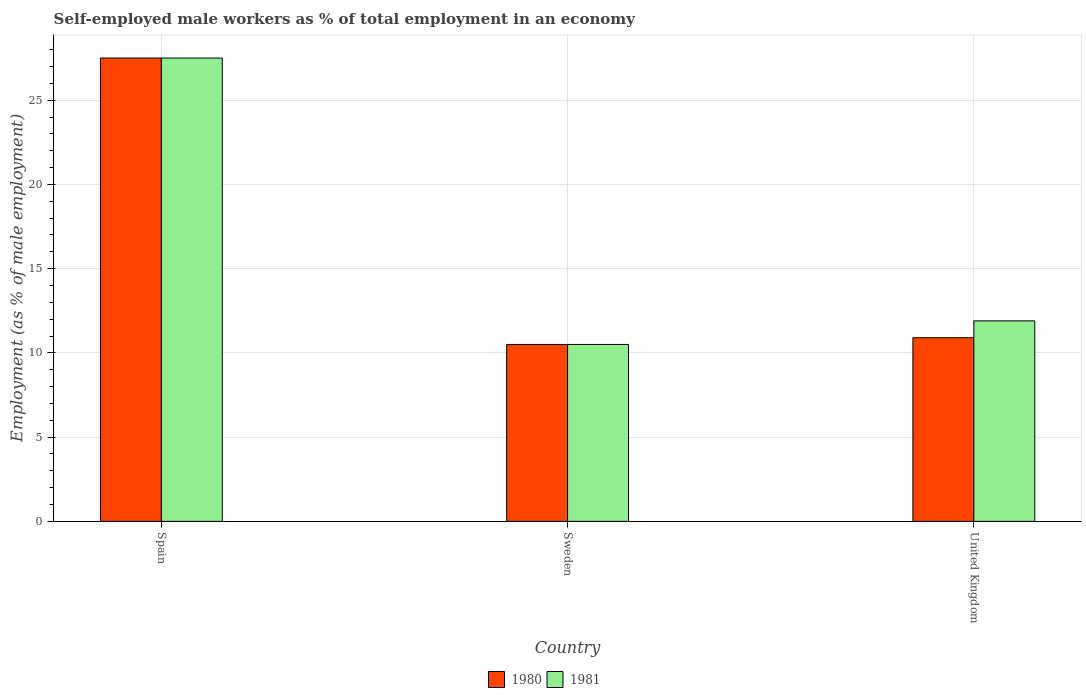How many bars are there on the 1st tick from the right?
Provide a succinct answer. 2. What is the label of the 1st group of bars from the left?
Offer a very short reply. Spain. In how many cases, is the number of bars for a given country not equal to the number of legend labels?
Your answer should be compact. 0. What is the percentage of self-employed male workers in 1980 in Spain?
Offer a terse response. 27.5. Across all countries, what is the minimum percentage of self-employed male workers in 1981?
Your answer should be very brief. 10.5. What is the total percentage of self-employed male workers in 1980 in the graph?
Your answer should be very brief. 48.9. What is the difference between the percentage of self-employed male workers in 1981 in Sweden and that in United Kingdom?
Your answer should be very brief. -1.4. What is the difference between the percentage of self-employed male workers in 1981 in Sweden and the percentage of self-employed male workers in 1980 in United Kingdom?
Ensure brevity in your answer.  -0.4. What is the average percentage of self-employed male workers in 1980 per country?
Keep it short and to the point. 16.3. In how many countries, is the percentage of self-employed male workers in 1981 greater than 8 %?
Offer a terse response. 3. What is the ratio of the percentage of self-employed male workers in 1980 in Spain to that in Sweden?
Ensure brevity in your answer.  2.62. Is the difference between the percentage of self-employed male workers in 1980 in Sweden and United Kingdom greater than the difference between the percentage of self-employed male workers in 1981 in Sweden and United Kingdom?
Make the answer very short. Yes. What is the difference between the highest and the second highest percentage of self-employed male workers in 1981?
Ensure brevity in your answer.  1.4. What does the 2nd bar from the left in Sweden represents?
Ensure brevity in your answer.  1981. What does the 1st bar from the right in Sweden represents?
Provide a short and direct response. 1981. How many bars are there?
Your answer should be compact. 6. How many countries are there in the graph?
Provide a short and direct response. 3. Are the values on the major ticks of Y-axis written in scientific E-notation?
Your answer should be very brief. No. Where does the legend appear in the graph?
Your response must be concise. Bottom center. How many legend labels are there?
Your answer should be very brief. 2. What is the title of the graph?
Provide a succinct answer. Self-employed male workers as % of total employment in an economy. Does "1976" appear as one of the legend labels in the graph?
Offer a very short reply. No. What is the label or title of the Y-axis?
Provide a short and direct response. Employment (as % of male employment). What is the Employment (as % of male employment) in 1980 in Sweden?
Make the answer very short. 10.5. What is the Employment (as % of male employment) of 1981 in Sweden?
Make the answer very short. 10.5. What is the Employment (as % of male employment) of 1980 in United Kingdom?
Give a very brief answer. 10.9. What is the Employment (as % of male employment) of 1981 in United Kingdom?
Your answer should be compact. 11.9. Across all countries, what is the maximum Employment (as % of male employment) in 1980?
Offer a terse response. 27.5. What is the total Employment (as % of male employment) in 1980 in the graph?
Your answer should be compact. 48.9. What is the total Employment (as % of male employment) in 1981 in the graph?
Ensure brevity in your answer.  49.9. What is the difference between the Employment (as % of male employment) of 1981 in Spain and that in Sweden?
Offer a very short reply. 17. What is the difference between the Employment (as % of male employment) of 1980 in Spain and that in United Kingdom?
Give a very brief answer. 16.6. What is the difference between the Employment (as % of male employment) of 1981 in Spain and that in United Kingdom?
Your response must be concise. 15.6. What is the difference between the Employment (as % of male employment) of 1981 in Sweden and that in United Kingdom?
Keep it short and to the point. -1.4. What is the difference between the Employment (as % of male employment) of 1980 in Spain and the Employment (as % of male employment) of 1981 in United Kingdom?
Provide a short and direct response. 15.6. What is the average Employment (as % of male employment) in 1981 per country?
Your response must be concise. 16.63. What is the ratio of the Employment (as % of male employment) of 1980 in Spain to that in Sweden?
Keep it short and to the point. 2.62. What is the ratio of the Employment (as % of male employment) of 1981 in Spain to that in Sweden?
Offer a terse response. 2.62. What is the ratio of the Employment (as % of male employment) of 1980 in Spain to that in United Kingdom?
Offer a terse response. 2.52. What is the ratio of the Employment (as % of male employment) in 1981 in Spain to that in United Kingdom?
Offer a very short reply. 2.31. What is the ratio of the Employment (as % of male employment) of 1980 in Sweden to that in United Kingdom?
Your answer should be very brief. 0.96. What is the ratio of the Employment (as % of male employment) of 1981 in Sweden to that in United Kingdom?
Your answer should be compact. 0.88. What is the difference between the highest and the lowest Employment (as % of male employment) of 1980?
Provide a short and direct response. 17. What is the difference between the highest and the lowest Employment (as % of male employment) of 1981?
Keep it short and to the point. 17. 